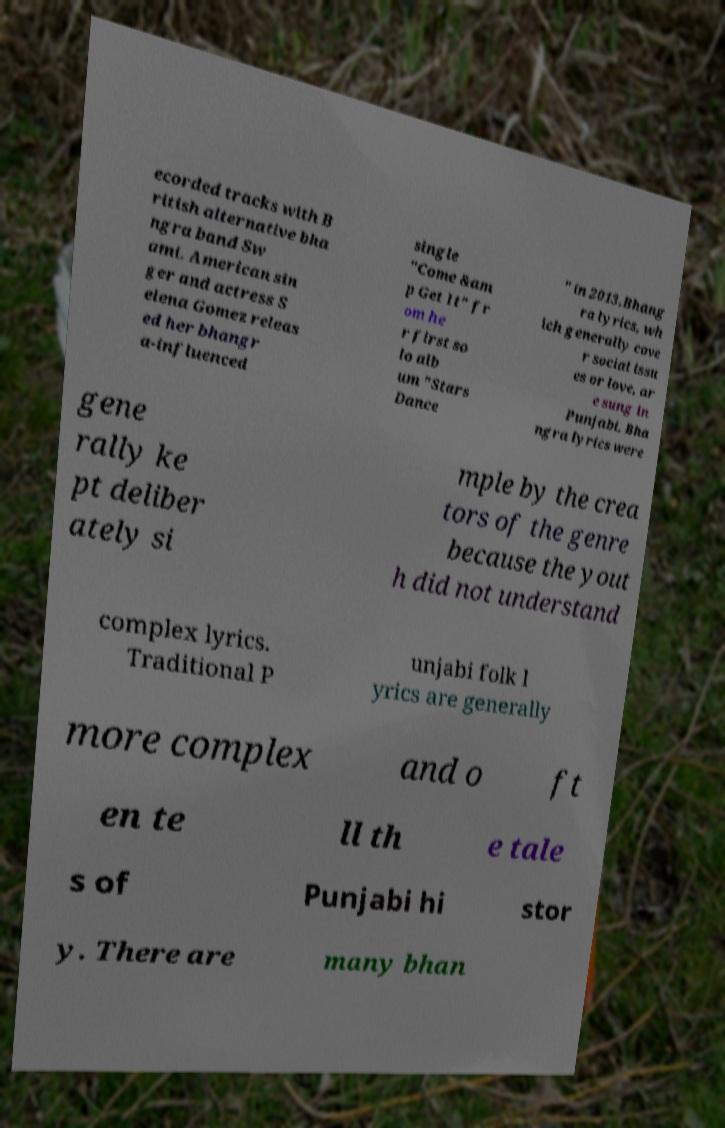Can you accurately transcribe the text from the provided image for me? ecorded tracks with B ritish alternative bha ngra band Sw ami. American sin ger and actress S elena Gomez releas ed her bhangr a-influenced single "Come &am p Get It" fr om he r first so lo alb um "Stars Dance " in 2013.Bhang ra lyrics, wh ich generally cove r social issu es or love, ar e sung in Punjabi. Bha ngra lyrics were gene rally ke pt deliber ately si mple by the crea tors of the genre because the yout h did not understand complex lyrics. Traditional P unjabi folk l yrics are generally more complex and o ft en te ll th e tale s of Punjabi hi stor y. There are many bhan 